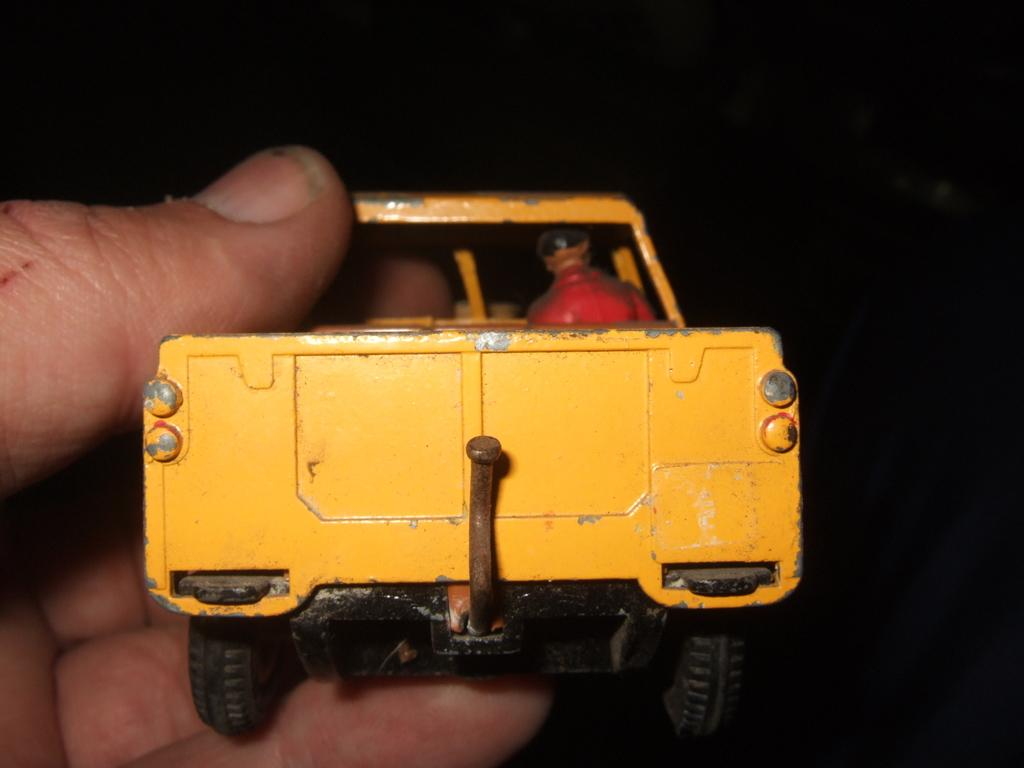What is the main subject of the image? The main subject of the image is a human hand. What is the hand holding in the image? The hand is holding a toy truck. How many dogs are present in the image? There are no dogs present in the image; it features a human hand holding a toy truck. What type of prison can be seen in the image? There is no prison present in the image; it features a human hand holding a toy truck. 